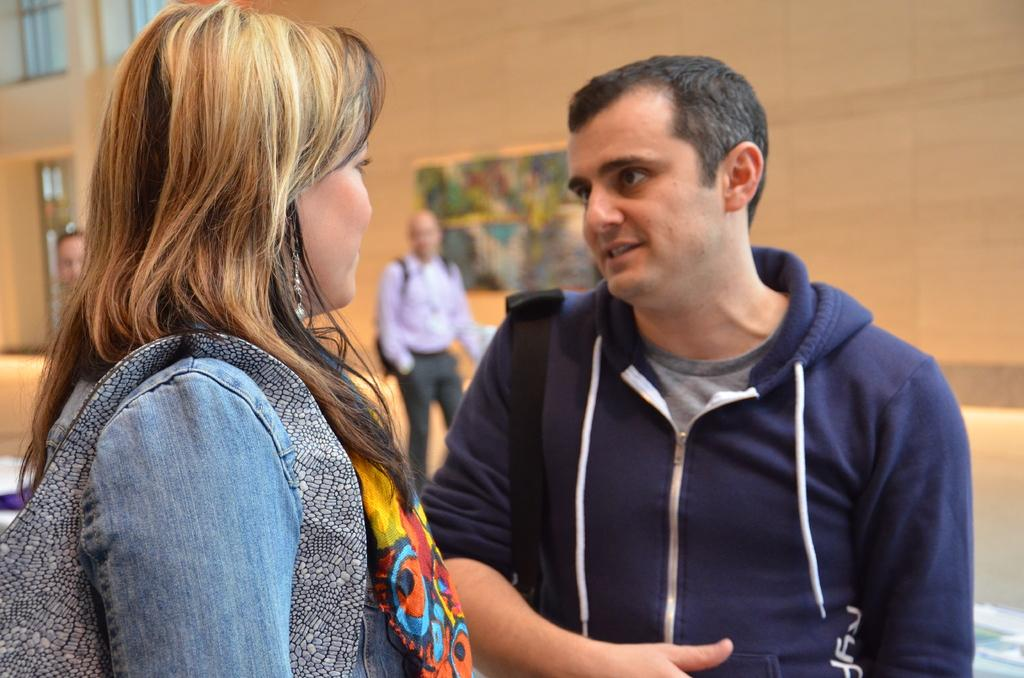How many people are present in the image? There are four people in the image: a man, a woman, and two people at the back. What can be seen in the background of the image? There are windows and a frame on the wall visible in the image. What is the quality of the background in the image? The background of the image is blurry. What type of box is being copied by the man in the image? There is no box or copying activity present in the image. What time of day is depicted in the image? The time of day cannot be determined from the image, as there are no specific time-related details provided. 